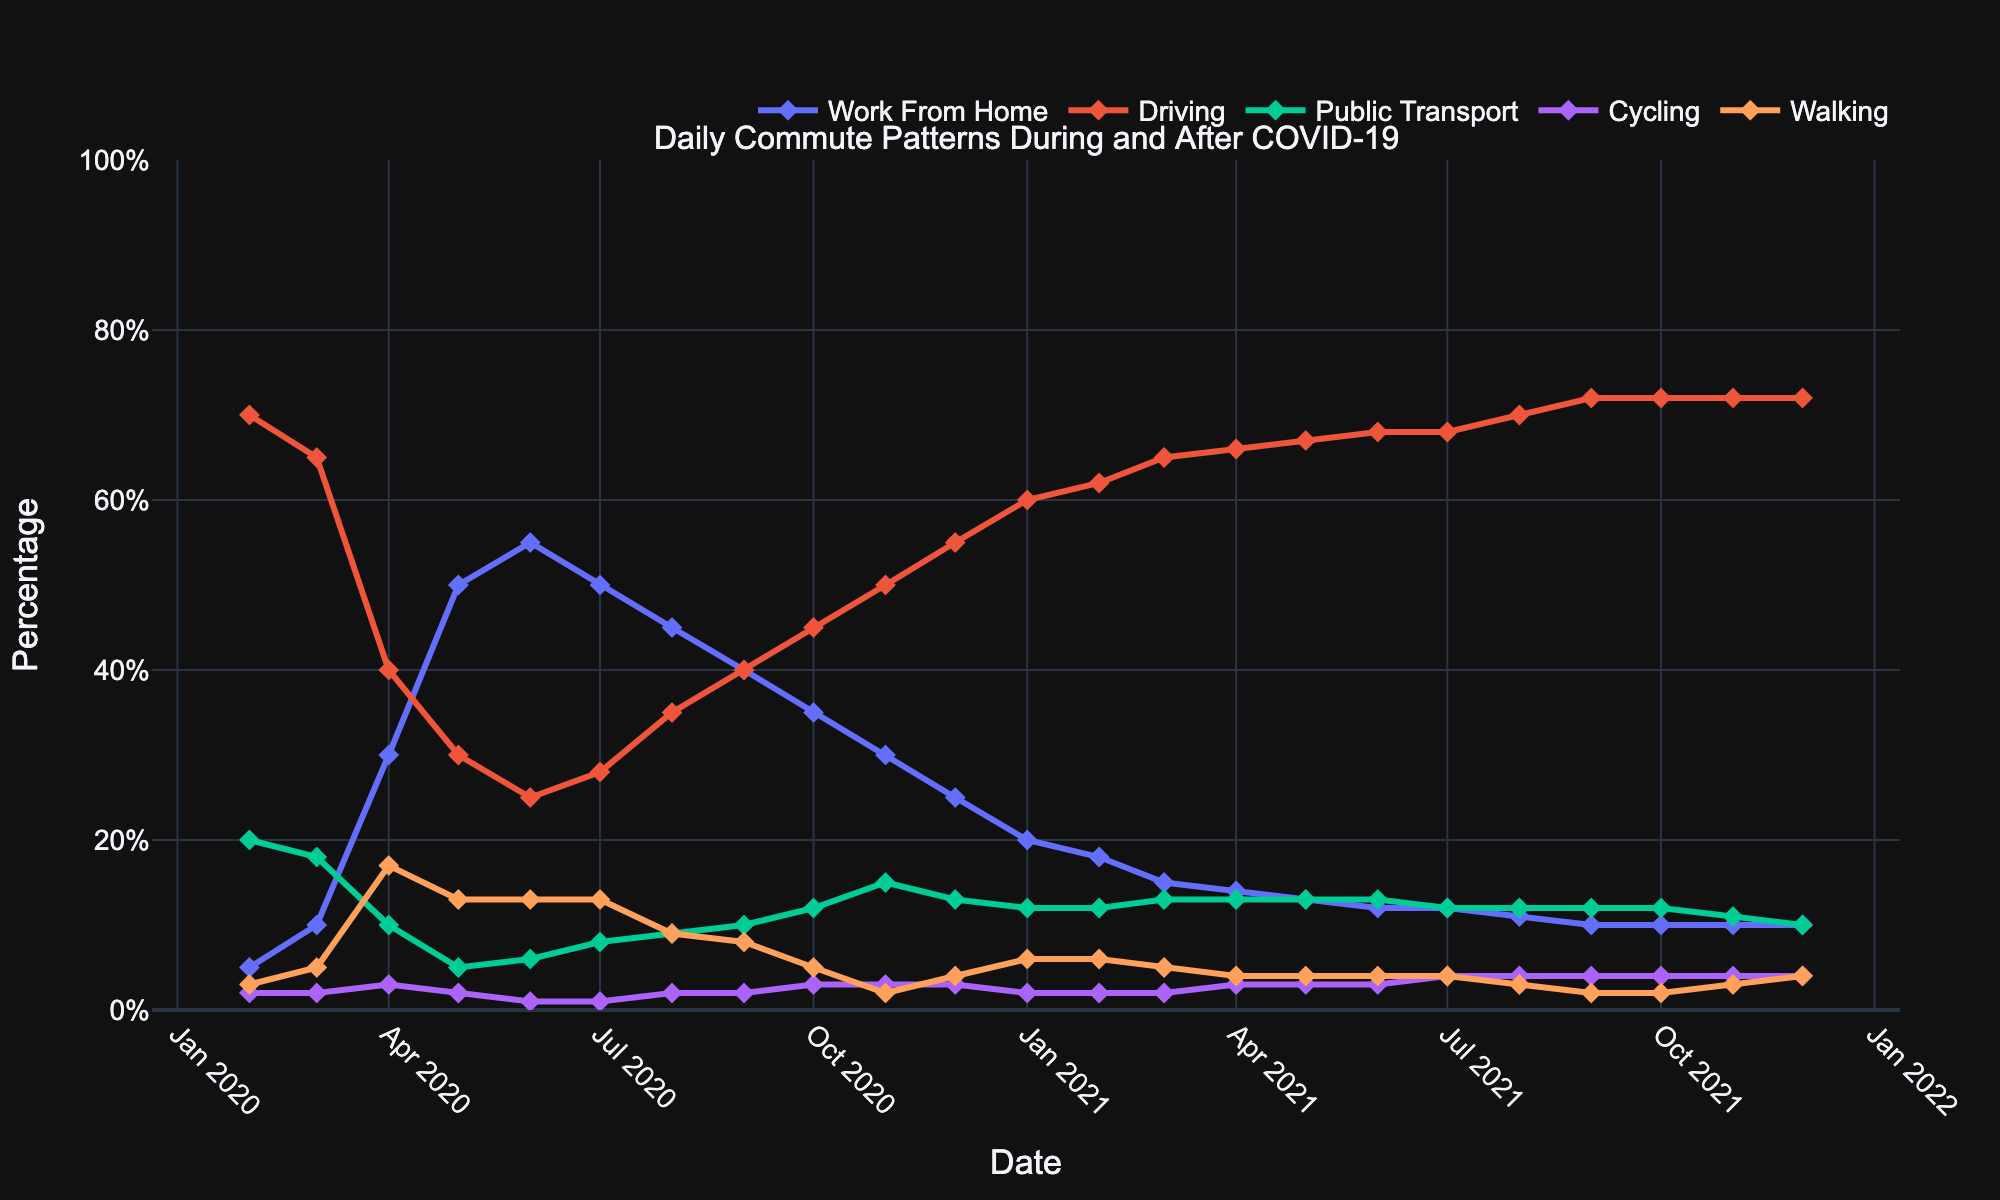What is the title of the plot? The title of the plot is located at the top and clearly states what the plot is about. In this case, it is specified as 'Daily Commute Patterns During and After COVID-19'.
Answer: Daily Commute Patterns During and After COVID-19 Which commute mode shows the highest percentage in the initial data point? Observe the first data point on the plot for each commute mode. The commute mode with the highest percentage is "driving," which starts at 70%.
Answer: Driving What trend do we observe for the 'work from home' commute mode from February 2020 to July 2020? Look at the trend line for 'work from home' from Feb 2020 to Jul 2020. It starts at 5% and rises significantly to 50%, peaking at 55% in June before a slight decrease.
Answer: Rising trend How did the percentage of people using public transport change from April 2020 to December 2020? Observe the percentage values for 'public transport' in April and December 2020. In April it was at 10%, and in December it increased slightly to 13%.
Answer: Increased by 3% What was the percentage difference between driving and work from home in May 2020? Check the values for 'driving' and 'work from home' in May 2020. Driving is at 30% and work from home is at 50%. The difference is 50% - 30%.
Answer: 20% Compare the percentage of people walking in April 2020 and April 2021. Check the values for 'walking' in April 2020 and April 2021. In April 2020, it is 17%, and in April 2021, it is 4%.
Answer: 13% decrease What was the percentage of people cycling in July 2021? Look at the value of the 'cycling' plot in July 2021; the percentage is marked at 4% in that month.
Answer: 4% Which commute mode showed the most consistent trend from January 2021 to December 2021? Review the trends for all commute modes from Jan 2021 to Dec 2021. Driving showed the most consistent trend, remaining around 70-72%.
Answer: Driving What month in 2020 had the highest percentage of people working from home? Follow the 'work from home' trend and find the peak value in 2020. The peak occurs in June 2020 at 55%.
Answer: June 2020 Between February and December 2020, how did the percentage of people cycling change? Compare the values of 'cycling' in February 2020 and December 2020. It was at 2% in Feb and 3% in Dec, showing a 1% increase.
Answer: Increased by 1% 